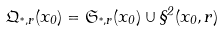<formula> <loc_0><loc_0><loc_500><loc_500>\mathfrak Q _ { ^ { * } , r } ( x _ { 0 } ) = \mathfrak S _ { ^ { * } , r } ( x _ { 0 } ) \cup \S ^ { 2 } ( x _ { 0 } , r )</formula> 